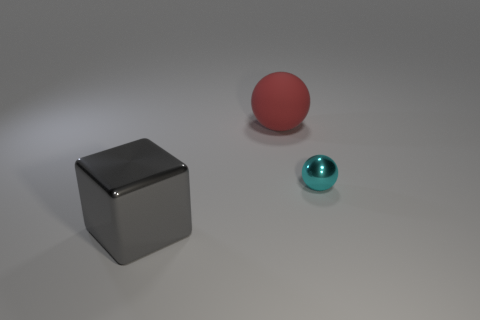Are there any other things that are made of the same material as the red ball?
Keep it short and to the point. No. Are there any other things that are the same shape as the gray thing?
Keep it short and to the point. No. Is there another matte object of the same shape as the small object?
Your answer should be very brief. Yes. What is the material of the red sphere?
Offer a very short reply. Rubber. Are there any large gray metallic objects left of the metallic sphere?
Offer a terse response. Yes. Is the shape of the big gray object the same as the rubber object?
Provide a succinct answer. No. How many other objects are there of the same size as the red rubber object?
Offer a very short reply. 1. What number of objects are either spheres that are to the left of the small cyan sphere or tiny spheres?
Offer a very short reply. 2. What is the color of the tiny shiny ball?
Give a very brief answer. Cyan. There is a big thing right of the big shiny block; what is it made of?
Provide a succinct answer. Rubber. 